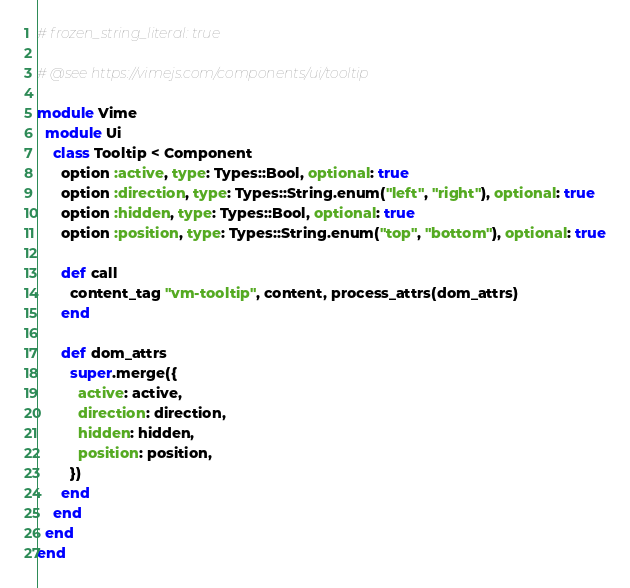Convert code to text. <code><loc_0><loc_0><loc_500><loc_500><_Ruby_># frozen_string_literal: true

# @see https://vimejs.com/components/ui/tooltip

module Vime
  module Ui
    class Tooltip < Component
      option :active, type: Types::Bool, optional: true
      option :direction, type: Types::String.enum("left", "right"), optional: true
      option :hidden, type: Types::Bool, optional: true
      option :position, type: Types::String.enum("top", "bottom"), optional: true

      def call
        content_tag "vm-tooltip", content, process_attrs(dom_attrs)
      end

      def dom_attrs
        super.merge({
          active: active,
          direction: direction,
          hidden: hidden,
          position: position,
        })
      end
    end
  end
end
</code> 